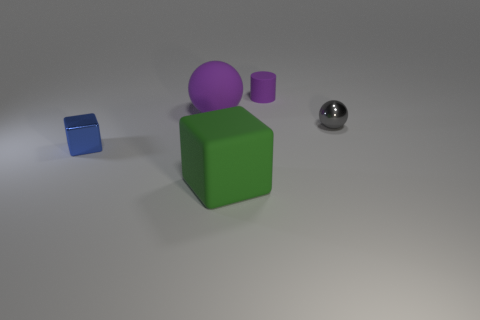There is a metallic thing on the left side of the purple rubber cylinder; are there any large objects that are behind it?
Ensure brevity in your answer.  Yes. What color is the tiny metal object that is right of the tiny blue cube?
Provide a succinct answer. Gray. Are there the same number of small gray metal things that are on the left side of the large purple matte thing and large blue metal things?
Your answer should be very brief. Yes. There is a thing that is behind the small gray metallic sphere and to the left of the tiny matte cylinder; what shape is it?
Your answer should be very brief. Sphere. What color is the other thing that is the same shape as the tiny blue metal thing?
Provide a short and direct response. Green. Is there anything else that is the same color as the small ball?
Your response must be concise. No. What shape is the large matte object behind the large rubber thing that is in front of the metal object that is on the left side of the small ball?
Provide a succinct answer. Sphere. There is a metallic object behind the tiny block; does it have the same size as the rubber thing in front of the tiny sphere?
Provide a succinct answer. No. What number of green cubes are the same material as the cylinder?
Offer a terse response. 1. How many green things are in front of the cube that is to the right of the big rubber thing that is behind the blue cube?
Offer a very short reply. 0. 